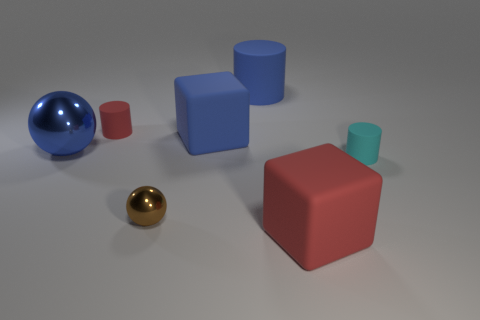Add 2 tiny red cylinders. How many objects exist? 9 Subtract all cylinders. How many objects are left? 4 Subtract all big blue matte blocks. Subtract all tiny cyan objects. How many objects are left? 5 Add 4 cylinders. How many cylinders are left? 7 Add 5 blue things. How many blue things exist? 8 Subtract 1 blue cylinders. How many objects are left? 6 